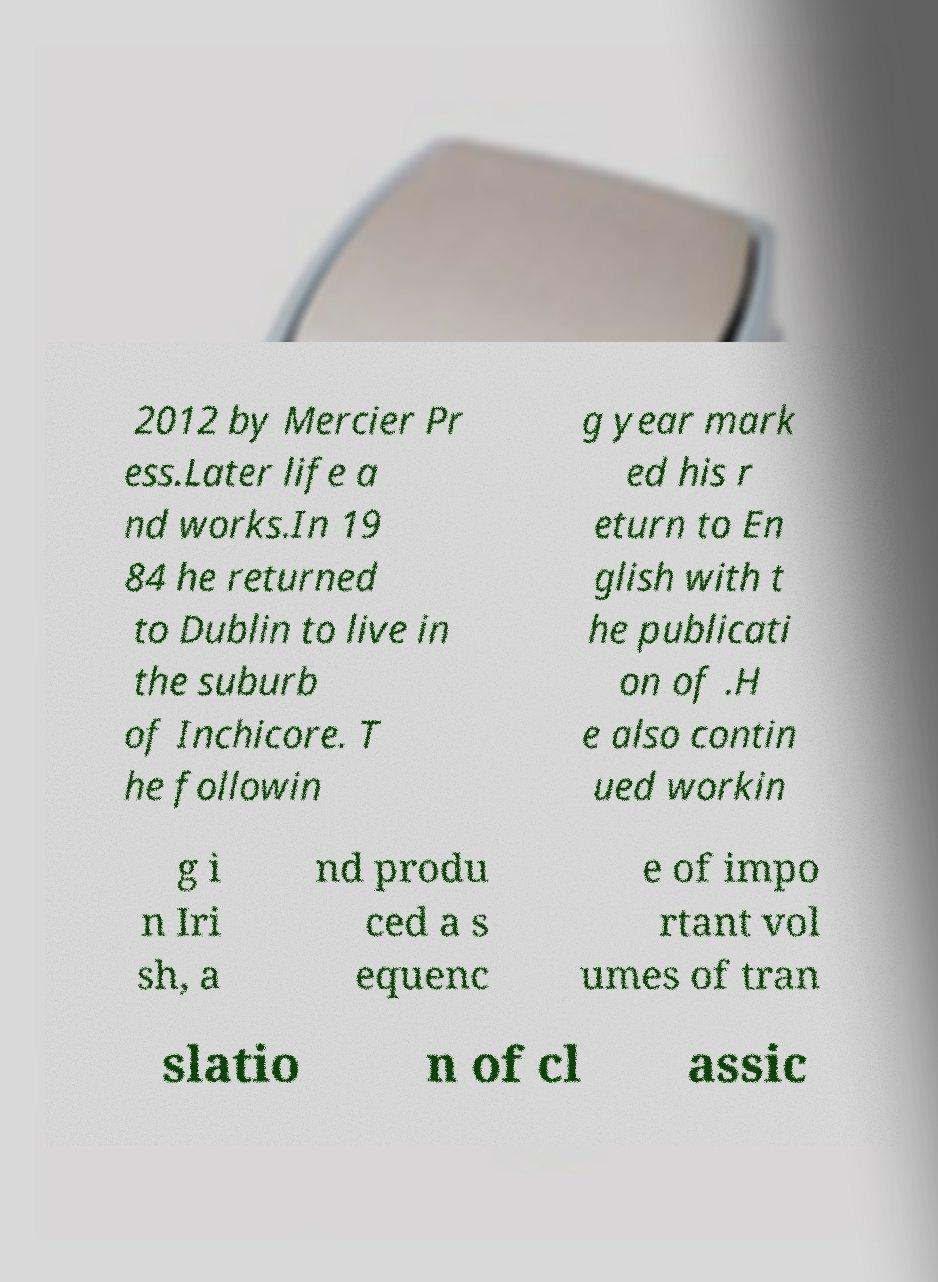What messages or text are displayed in this image? I need them in a readable, typed format. 2012 by Mercier Pr ess.Later life a nd works.In 19 84 he returned to Dublin to live in the suburb of Inchicore. T he followin g year mark ed his r eturn to En glish with t he publicati on of .H e also contin ued workin g i n Iri sh, a nd produ ced a s equenc e of impo rtant vol umes of tran slatio n of cl assic 